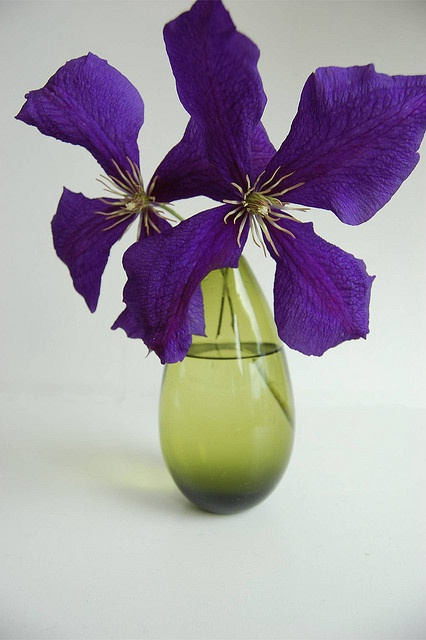Describe the objects in this image and their specific colors. I can see a vase in darkgray, khaki, darkgreen, and olive tones in this image. 